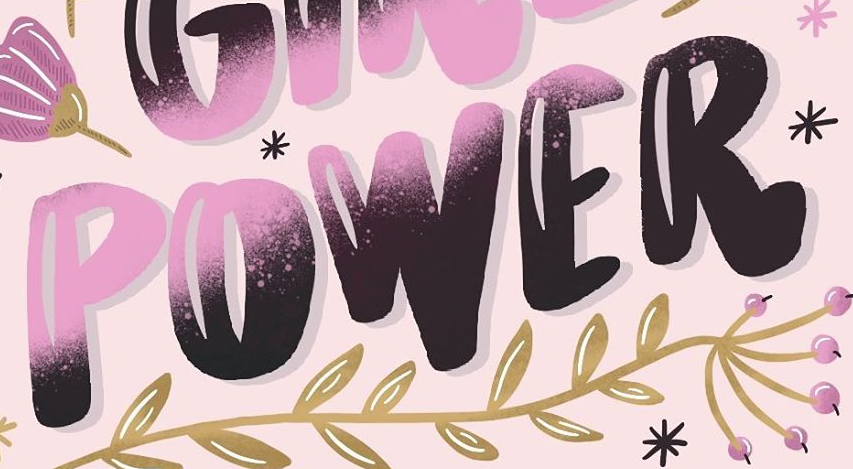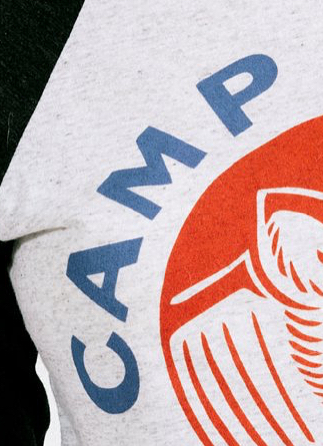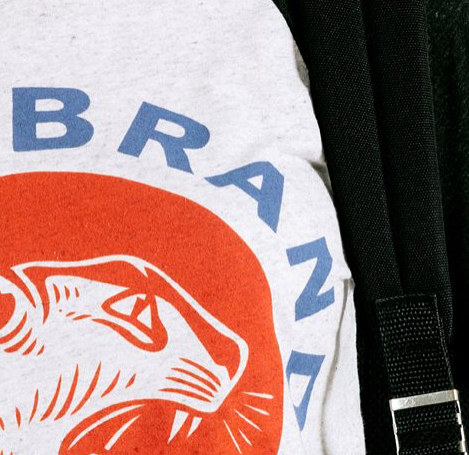What words can you see in these images in sequence, separated by a semicolon? POWER; CAMP; BRAND 